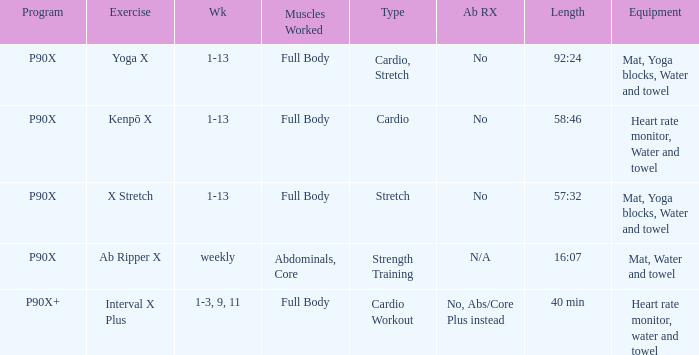What is the ab ripper x when the length is 92:24? No. 